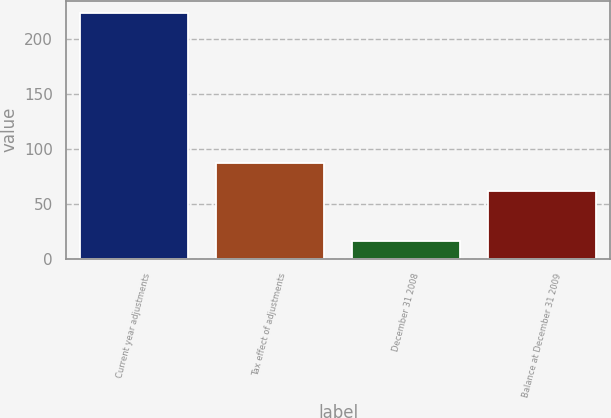<chart> <loc_0><loc_0><loc_500><loc_500><bar_chart><fcel>Current year adjustments<fcel>Tax effect of adjustments<fcel>December 31 2008<fcel>Balance at December 31 2009<nl><fcel>224.1<fcel>87.4<fcel>16.7<fcel>61.5<nl></chart> 